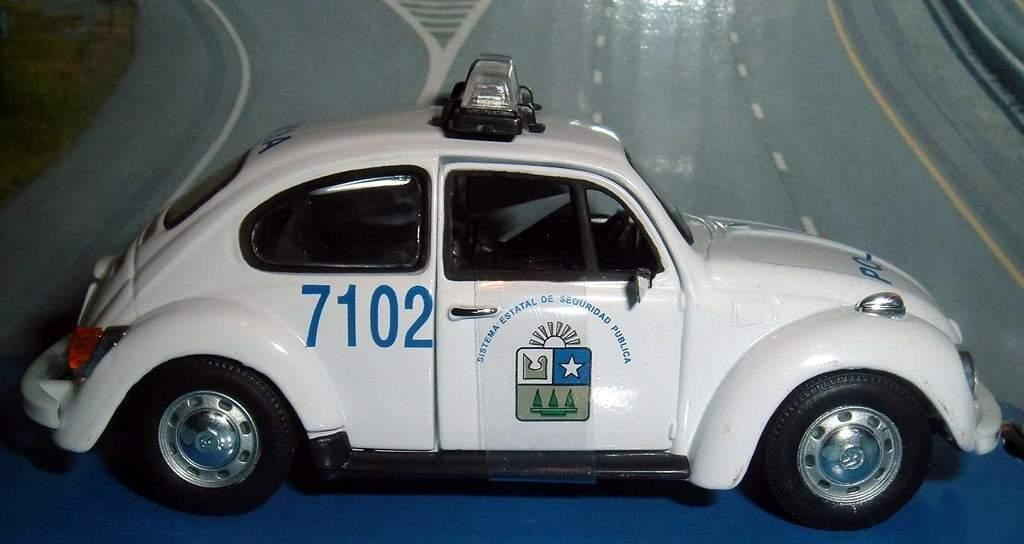What color is the car in the image? The car in the image is white. What features can be seen on the car? The car has lights and some text on it. What is the background of the image? The background of the image appears to be a road. What type of rock can be seen in the car's engine in the image? There is no rock visible in the car's engine in the image, as the image does not show the car's engine. 